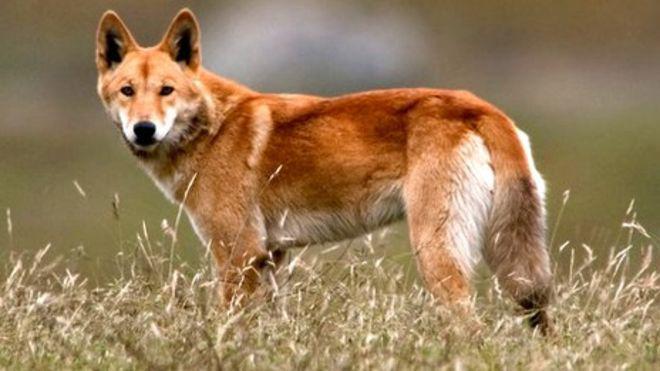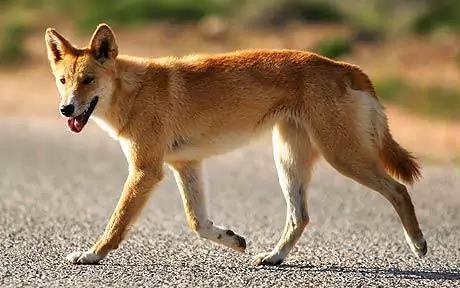The first image is the image on the left, the second image is the image on the right. Considering the images on both sides, is "There is at least one image there is a single yellow and white dog facing right with their heads turned left." valid? Answer yes or no. No. The first image is the image on the left, the second image is the image on the right. Analyze the images presented: Is the assertion "In one image, the animal is standing over grass or other plant life." valid? Answer yes or no. Yes. 